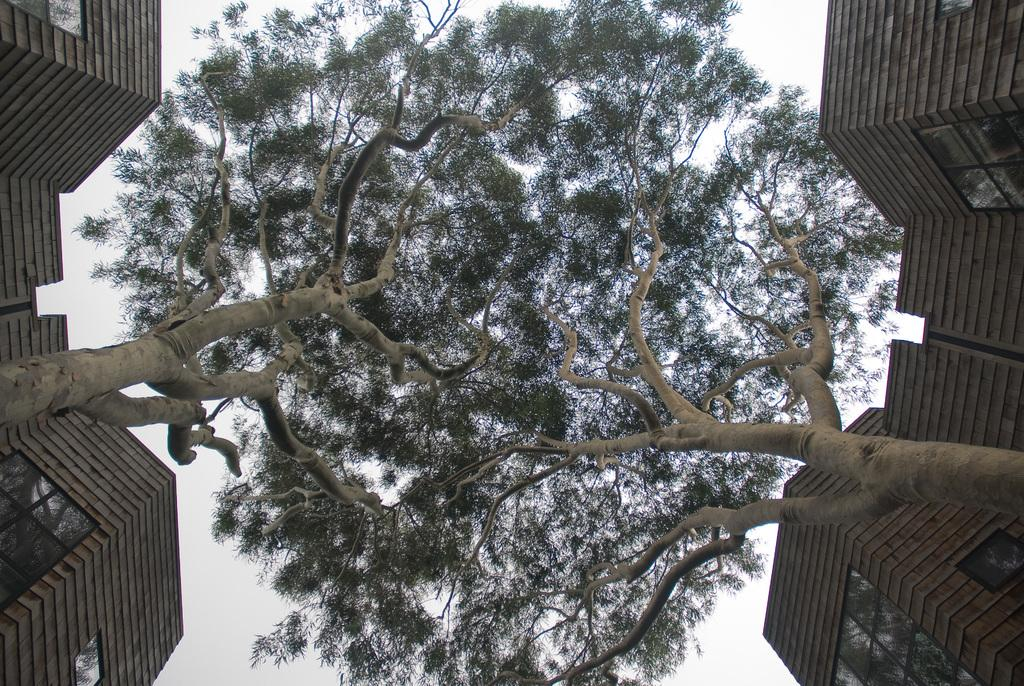What structures are located on the left side of the image? There are buildings on the left side of the image. What structures are located on the right side of the image? There are buildings on the right side of the image. What type of vegetation is visible in the image? There are trees visible in the image. Where is the toothbrush located in the image? There is no toothbrush present in the image. What type of car can be seen driving through the buildings in the image? There is no car visible in the image; it only features buildings and trees. 